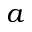<formula> <loc_0><loc_0><loc_500><loc_500>a</formula> 